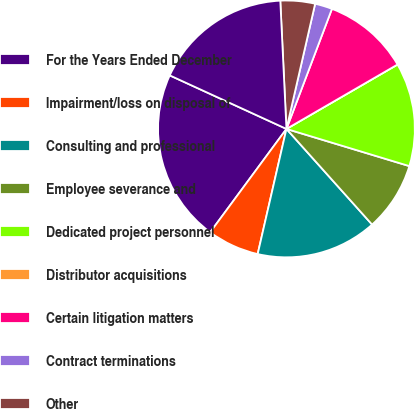<chart> <loc_0><loc_0><loc_500><loc_500><pie_chart><fcel>For the Years Ended December<fcel>Impairment/loss on disposal of<fcel>Consulting and professional<fcel>Employee severance and<fcel>Dedicated project personnel<fcel>Distributor acquisitions<fcel>Certain litigation matters<fcel>Contract terminations<fcel>Other<fcel>Special items<nl><fcel>21.73%<fcel>6.52%<fcel>15.22%<fcel>8.7%<fcel>13.04%<fcel>0.0%<fcel>10.87%<fcel>2.18%<fcel>4.35%<fcel>17.39%<nl></chart> 